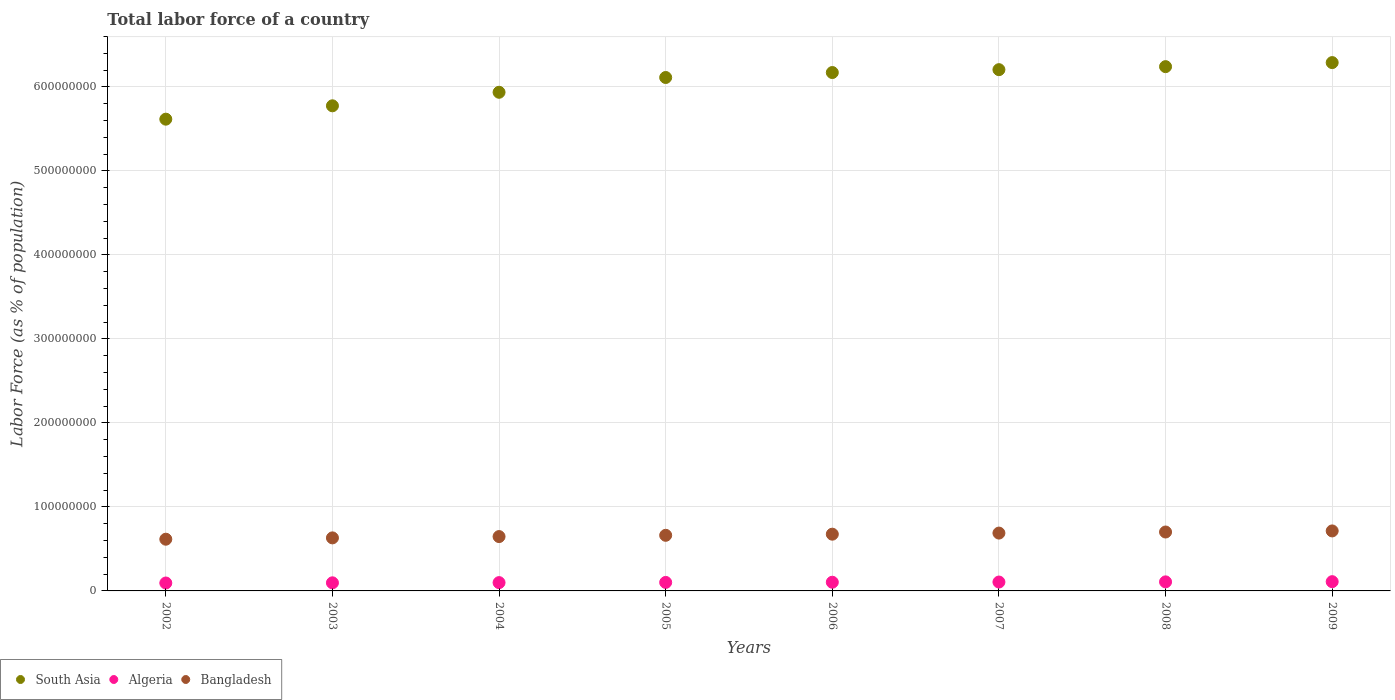How many different coloured dotlines are there?
Provide a short and direct response. 3. Is the number of dotlines equal to the number of legend labels?
Give a very brief answer. Yes. What is the percentage of labor force in Algeria in 2007?
Provide a short and direct response. 1.06e+07. Across all years, what is the maximum percentage of labor force in Bangladesh?
Give a very brief answer. 7.14e+07. Across all years, what is the minimum percentage of labor force in Algeria?
Offer a very short reply. 9.43e+06. What is the total percentage of labor force in Bangladesh in the graph?
Offer a terse response. 5.34e+08. What is the difference between the percentage of labor force in Bangladesh in 2006 and that in 2009?
Provide a succinct answer. -3.87e+06. What is the difference between the percentage of labor force in Algeria in 2003 and the percentage of labor force in Bangladesh in 2005?
Give a very brief answer. -5.66e+07. What is the average percentage of labor force in Algeria per year?
Offer a very short reply. 1.02e+07. In the year 2004, what is the difference between the percentage of labor force in Algeria and percentage of labor force in South Asia?
Your answer should be very brief. -5.84e+08. In how many years, is the percentage of labor force in Bangladesh greater than 80000000 %?
Make the answer very short. 0. What is the ratio of the percentage of labor force in South Asia in 2002 to that in 2003?
Offer a terse response. 0.97. Is the difference between the percentage of labor force in Algeria in 2005 and 2007 greater than the difference between the percentage of labor force in South Asia in 2005 and 2007?
Ensure brevity in your answer.  Yes. What is the difference between the highest and the second highest percentage of labor force in Bangladesh?
Ensure brevity in your answer.  1.29e+06. What is the difference between the highest and the lowest percentage of labor force in Bangladesh?
Provide a succinct answer. 9.86e+06. In how many years, is the percentage of labor force in South Asia greater than the average percentage of labor force in South Asia taken over all years?
Offer a terse response. 5. Does the percentage of labor force in South Asia monotonically increase over the years?
Make the answer very short. Yes. Is the percentage of labor force in South Asia strictly less than the percentage of labor force in Bangladesh over the years?
Keep it short and to the point. No. How many years are there in the graph?
Offer a terse response. 8. Does the graph contain any zero values?
Give a very brief answer. No. How are the legend labels stacked?
Your answer should be very brief. Horizontal. What is the title of the graph?
Provide a succinct answer. Total labor force of a country. What is the label or title of the Y-axis?
Make the answer very short. Labor Force (as % of population). What is the Labor Force (as % of population) in South Asia in 2002?
Your answer should be compact. 5.62e+08. What is the Labor Force (as % of population) of Algeria in 2002?
Offer a very short reply. 9.43e+06. What is the Labor Force (as % of population) of Bangladesh in 2002?
Your answer should be compact. 6.16e+07. What is the Labor Force (as % of population) in South Asia in 2003?
Offer a very short reply. 5.78e+08. What is the Labor Force (as % of population) in Algeria in 2003?
Ensure brevity in your answer.  9.65e+06. What is the Labor Force (as % of population) of Bangladesh in 2003?
Your response must be concise. 6.32e+07. What is the Labor Force (as % of population) in South Asia in 2004?
Provide a succinct answer. 5.94e+08. What is the Labor Force (as % of population) in Algeria in 2004?
Your answer should be very brief. 9.89e+06. What is the Labor Force (as % of population) of Bangladesh in 2004?
Make the answer very short. 6.47e+07. What is the Labor Force (as % of population) in South Asia in 2005?
Your response must be concise. 6.11e+08. What is the Labor Force (as % of population) in Algeria in 2005?
Your answer should be very brief. 1.01e+07. What is the Labor Force (as % of population) of Bangladesh in 2005?
Keep it short and to the point. 6.62e+07. What is the Labor Force (as % of population) in South Asia in 2006?
Your response must be concise. 6.17e+08. What is the Labor Force (as % of population) of Algeria in 2006?
Provide a short and direct response. 1.03e+07. What is the Labor Force (as % of population) of Bangladesh in 2006?
Your answer should be very brief. 6.76e+07. What is the Labor Force (as % of population) of South Asia in 2007?
Provide a short and direct response. 6.21e+08. What is the Labor Force (as % of population) of Algeria in 2007?
Keep it short and to the point. 1.06e+07. What is the Labor Force (as % of population) in Bangladesh in 2007?
Your response must be concise. 6.89e+07. What is the Labor Force (as % of population) in South Asia in 2008?
Make the answer very short. 6.24e+08. What is the Labor Force (as % of population) of Algeria in 2008?
Keep it short and to the point. 1.08e+07. What is the Labor Force (as % of population) of Bangladesh in 2008?
Give a very brief answer. 7.01e+07. What is the Labor Force (as % of population) of South Asia in 2009?
Ensure brevity in your answer.  6.29e+08. What is the Labor Force (as % of population) in Algeria in 2009?
Your answer should be compact. 1.10e+07. What is the Labor Force (as % of population) in Bangladesh in 2009?
Make the answer very short. 7.14e+07. Across all years, what is the maximum Labor Force (as % of population) in South Asia?
Keep it short and to the point. 6.29e+08. Across all years, what is the maximum Labor Force (as % of population) of Algeria?
Give a very brief answer. 1.10e+07. Across all years, what is the maximum Labor Force (as % of population) of Bangladesh?
Keep it short and to the point. 7.14e+07. Across all years, what is the minimum Labor Force (as % of population) in South Asia?
Keep it short and to the point. 5.62e+08. Across all years, what is the minimum Labor Force (as % of population) in Algeria?
Offer a terse response. 9.43e+06. Across all years, what is the minimum Labor Force (as % of population) of Bangladesh?
Make the answer very short. 6.16e+07. What is the total Labor Force (as % of population) in South Asia in the graph?
Your answer should be very brief. 4.84e+09. What is the total Labor Force (as % of population) in Algeria in the graph?
Offer a very short reply. 8.18e+07. What is the total Labor Force (as % of population) in Bangladesh in the graph?
Give a very brief answer. 5.34e+08. What is the difference between the Labor Force (as % of population) in South Asia in 2002 and that in 2003?
Ensure brevity in your answer.  -1.59e+07. What is the difference between the Labor Force (as % of population) of Algeria in 2002 and that in 2003?
Your response must be concise. -2.21e+05. What is the difference between the Labor Force (as % of population) of Bangladesh in 2002 and that in 2003?
Ensure brevity in your answer.  -1.58e+06. What is the difference between the Labor Force (as % of population) in South Asia in 2002 and that in 2004?
Your answer should be compact. -3.20e+07. What is the difference between the Labor Force (as % of population) in Algeria in 2002 and that in 2004?
Provide a succinct answer. -4.60e+05. What is the difference between the Labor Force (as % of population) of Bangladesh in 2002 and that in 2004?
Your answer should be compact. -3.14e+06. What is the difference between the Labor Force (as % of population) in South Asia in 2002 and that in 2005?
Your response must be concise. -4.96e+07. What is the difference between the Labor Force (as % of population) in Algeria in 2002 and that in 2005?
Offer a very short reply. -6.96e+05. What is the difference between the Labor Force (as % of population) of Bangladesh in 2002 and that in 2005?
Provide a short and direct response. -4.65e+06. What is the difference between the Labor Force (as % of population) in South Asia in 2002 and that in 2006?
Ensure brevity in your answer.  -5.55e+07. What is the difference between the Labor Force (as % of population) of Algeria in 2002 and that in 2006?
Your answer should be very brief. -9.16e+05. What is the difference between the Labor Force (as % of population) in Bangladesh in 2002 and that in 2006?
Ensure brevity in your answer.  -5.99e+06. What is the difference between the Labor Force (as % of population) of South Asia in 2002 and that in 2007?
Make the answer very short. -5.90e+07. What is the difference between the Labor Force (as % of population) of Algeria in 2002 and that in 2007?
Offer a very short reply. -1.15e+06. What is the difference between the Labor Force (as % of population) of Bangladesh in 2002 and that in 2007?
Keep it short and to the point. -7.29e+06. What is the difference between the Labor Force (as % of population) of South Asia in 2002 and that in 2008?
Give a very brief answer. -6.25e+07. What is the difference between the Labor Force (as % of population) in Algeria in 2002 and that in 2008?
Offer a terse response. -1.35e+06. What is the difference between the Labor Force (as % of population) of Bangladesh in 2002 and that in 2008?
Offer a terse response. -8.57e+06. What is the difference between the Labor Force (as % of population) in South Asia in 2002 and that in 2009?
Keep it short and to the point. -6.74e+07. What is the difference between the Labor Force (as % of population) in Algeria in 2002 and that in 2009?
Your answer should be very brief. -1.59e+06. What is the difference between the Labor Force (as % of population) in Bangladesh in 2002 and that in 2009?
Ensure brevity in your answer.  -9.86e+06. What is the difference between the Labor Force (as % of population) in South Asia in 2003 and that in 2004?
Your answer should be compact. -1.61e+07. What is the difference between the Labor Force (as % of population) of Algeria in 2003 and that in 2004?
Give a very brief answer. -2.39e+05. What is the difference between the Labor Force (as % of population) in Bangladesh in 2003 and that in 2004?
Give a very brief answer. -1.55e+06. What is the difference between the Labor Force (as % of population) in South Asia in 2003 and that in 2005?
Your answer should be very brief. -3.37e+07. What is the difference between the Labor Force (as % of population) of Algeria in 2003 and that in 2005?
Your response must be concise. -4.75e+05. What is the difference between the Labor Force (as % of population) of Bangladesh in 2003 and that in 2005?
Ensure brevity in your answer.  -3.06e+06. What is the difference between the Labor Force (as % of population) of South Asia in 2003 and that in 2006?
Provide a succinct answer. -3.96e+07. What is the difference between the Labor Force (as % of population) in Algeria in 2003 and that in 2006?
Offer a terse response. -6.95e+05. What is the difference between the Labor Force (as % of population) of Bangladesh in 2003 and that in 2006?
Your answer should be compact. -4.41e+06. What is the difference between the Labor Force (as % of population) of South Asia in 2003 and that in 2007?
Make the answer very short. -4.30e+07. What is the difference between the Labor Force (as % of population) of Algeria in 2003 and that in 2007?
Keep it short and to the point. -9.28e+05. What is the difference between the Labor Force (as % of population) of Bangladesh in 2003 and that in 2007?
Ensure brevity in your answer.  -5.71e+06. What is the difference between the Labor Force (as % of population) in South Asia in 2003 and that in 2008?
Your answer should be compact. -4.66e+07. What is the difference between the Labor Force (as % of population) of Algeria in 2003 and that in 2008?
Offer a very short reply. -1.13e+06. What is the difference between the Labor Force (as % of population) in Bangladesh in 2003 and that in 2008?
Provide a succinct answer. -6.99e+06. What is the difference between the Labor Force (as % of population) of South Asia in 2003 and that in 2009?
Your answer should be compact. -5.14e+07. What is the difference between the Labor Force (as % of population) of Algeria in 2003 and that in 2009?
Your answer should be compact. -1.37e+06. What is the difference between the Labor Force (as % of population) in Bangladesh in 2003 and that in 2009?
Keep it short and to the point. -8.28e+06. What is the difference between the Labor Force (as % of population) of South Asia in 2004 and that in 2005?
Offer a terse response. -1.76e+07. What is the difference between the Labor Force (as % of population) in Algeria in 2004 and that in 2005?
Your answer should be compact. -2.35e+05. What is the difference between the Labor Force (as % of population) in Bangladesh in 2004 and that in 2005?
Give a very brief answer. -1.51e+06. What is the difference between the Labor Force (as % of population) of South Asia in 2004 and that in 2006?
Make the answer very short. -2.35e+07. What is the difference between the Labor Force (as % of population) in Algeria in 2004 and that in 2006?
Your answer should be compact. -4.55e+05. What is the difference between the Labor Force (as % of population) of Bangladesh in 2004 and that in 2006?
Make the answer very short. -2.85e+06. What is the difference between the Labor Force (as % of population) in South Asia in 2004 and that in 2007?
Your answer should be very brief. -2.69e+07. What is the difference between the Labor Force (as % of population) of Algeria in 2004 and that in 2007?
Your response must be concise. -6.88e+05. What is the difference between the Labor Force (as % of population) in Bangladesh in 2004 and that in 2007?
Offer a very short reply. -4.15e+06. What is the difference between the Labor Force (as % of population) in South Asia in 2004 and that in 2008?
Give a very brief answer. -3.05e+07. What is the difference between the Labor Force (as % of population) in Algeria in 2004 and that in 2008?
Your response must be concise. -8.87e+05. What is the difference between the Labor Force (as % of population) of Bangladesh in 2004 and that in 2008?
Provide a succinct answer. -5.44e+06. What is the difference between the Labor Force (as % of population) in South Asia in 2004 and that in 2009?
Make the answer very short. -3.53e+07. What is the difference between the Labor Force (as % of population) of Algeria in 2004 and that in 2009?
Keep it short and to the point. -1.13e+06. What is the difference between the Labor Force (as % of population) of Bangladesh in 2004 and that in 2009?
Make the answer very short. -6.73e+06. What is the difference between the Labor Force (as % of population) of South Asia in 2005 and that in 2006?
Keep it short and to the point. -5.91e+06. What is the difference between the Labor Force (as % of population) in Algeria in 2005 and that in 2006?
Make the answer very short. -2.20e+05. What is the difference between the Labor Force (as % of population) of Bangladesh in 2005 and that in 2006?
Offer a very short reply. -1.34e+06. What is the difference between the Labor Force (as % of population) in South Asia in 2005 and that in 2007?
Provide a succinct answer. -9.34e+06. What is the difference between the Labor Force (as % of population) of Algeria in 2005 and that in 2007?
Offer a very short reply. -4.53e+05. What is the difference between the Labor Force (as % of population) of Bangladesh in 2005 and that in 2007?
Keep it short and to the point. -2.65e+06. What is the difference between the Labor Force (as % of population) in South Asia in 2005 and that in 2008?
Provide a short and direct response. -1.29e+07. What is the difference between the Labor Force (as % of population) in Algeria in 2005 and that in 2008?
Your answer should be very brief. -6.52e+05. What is the difference between the Labor Force (as % of population) in Bangladesh in 2005 and that in 2008?
Your answer should be very brief. -3.93e+06. What is the difference between the Labor Force (as % of population) in South Asia in 2005 and that in 2009?
Your answer should be compact. -1.77e+07. What is the difference between the Labor Force (as % of population) in Algeria in 2005 and that in 2009?
Offer a very short reply. -8.95e+05. What is the difference between the Labor Force (as % of population) in Bangladesh in 2005 and that in 2009?
Your response must be concise. -5.22e+06. What is the difference between the Labor Force (as % of population) in South Asia in 2006 and that in 2007?
Your answer should be very brief. -3.43e+06. What is the difference between the Labor Force (as % of population) in Algeria in 2006 and that in 2007?
Your answer should be very brief. -2.33e+05. What is the difference between the Labor Force (as % of population) of Bangladesh in 2006 and that in 2007?
Provide a succinct answer. -1.30e+06. What is the difference between the Labor Force (as % of population) in South Asia in 2006 and that in 2008?
Give a very brief answer. -7.01e+06. What is the difference between the Labor Force (as % of population) in Algeria in 2006 and that in 2008?
Ensure brevity in your answer.  -4.32e+05. What is the difference between the Labor Force (as % of population) in Bangladesh in 2006 and that in 2008?
Ensure brevity in your answer.  -2.58e+06. What is the difference between the Labor Force (as % of population) of South Asia in 2006 and that in 2009?
Give a very brief answer. -1.18e+07. What is the difference between the Labor Force (as % of population) of Algeria in 2006 and that in 2009?
Provide a short and direct response. -6.75e+05. What is the difference between the Labor Force (as % of population) in Bangladesh in 2006 and that in 2009?
Your answer should be compact. -3.87e+06. What is the difference between the Labor Force (as % of population) in South Asia in 2007 and that in 2008?
Ensure brevity in your answer.  -3.58e+06. What is the difference between the Labor Force (as % of population) of Algeria in 2007 and that in 2008?
Offer a very short reply. -1.99e+05. What is the difference between the Labor Force (as % of population) of Bangladesh in 2007 and that in 2008?
Offer a very short reply. -1.28e+06. What is the difference between the Labor Force (as % of population) in South Asia in 2007 and that in 2009?
Make the answer very short. -8.41e+06. What is the difference between the Labor Force (as % of population) of Algeria in 2007 and that in 2009?
Your answer should be very brief. -4.42e+05. What is the difference between the Labor Force (as % of population) of Bangladesh in 2007 and that in 2009?
Your response must be concise. -2.57e+06. What is the difference between the Labor Force (as % of population) of South Asia in 2008 and that in 2009?
Your answer should be very brief. -4.82e+06. What is the difference between the Labor Force (as % of population) in Algeria in 2008 and that in 2009?
Your answer should be compact. -2.43e+05. What is the difference between the Labor Force (as % of population) in Bangladesh in 2008 and that in 2009?
Give a very brief answer. -1.29e+06. What is the difference between the Labor Force (as % of population) in South Asia in 2002 and the Labor Force (as % of population) in Algeria in 2003?
Provide a short and direct response. 5.52e+08. What is the difference between the Labor Force (as % of population) in South Asia in 2002 and the Labor Force (as % of population) in Bangladesh in 2003?
Offer a terse response. 4.99e+08. What is the difference between the Labor Force (as % of population) of Algeria in 2002 and the Labor Force (as % of population) of Bangladesh in 2003?
Your response must be concise. -5.37e+07. What is the difference between the Labor Force (as % of population) of South Asia in 2002 and the Labor Force (as % of population) of Algeria in 2004?
Your response must be concise. 5.52e+08. What is the difference between the Labor Force (as % of population) of South Asia in 2002 and the Labor Force (as % of population) of Bangladesh in 2004?
Ensure brevity in your answer.  4.97e+08. What is the difference between the Labor Force (as % of population) of Algeria in 2002 and the Labor Force (as % of population) of Bangladesh in 2004?
Give a very brief answer. -5.53e+07. What is the difference between the Labor Force (as % of population) in South Asia in 2002 and the Labor Force (as % of population) in Algeria in 2005?
Give a very brief answer. 5.52e+08. What is the difference between the Labor Force (as % of population) of South Asia in 2002 and the Labor Force (as % of population) of Bangladesh in 2005?
Your response must be concise. 4.95e+08. What is the difference between the Labor Force (as % of population) in Algeria in 2002 and the Labor Force (as % of population) in Bangladesh in 2005?
Provide a short and direct response. -5.68e+07. What is the difference between the Labor Force (as % of population) of South Asia in 2002 and the Labor Force (as % of population) of Algeria in 2006?
Your response must be concise. 5.51e+08. What is the difference between the Labor Force (as % of population) of South Asia in 2002 and the Labor Force (as % of population) of Bangladesh in 2006?
Provide a succinct answer. 4.94e+08. What is the difference between the Labor Force (as % of population) in Algeria in 2002 and the Labor Force (as % of population) in Bangladesh in 2006?
Your answer should be compact. -5.81e+07. What is the difference between the Labor Force (as % of population) of South Asia in 2002 and the Labor Force (as % of population) of Algeria in 2007?
Keep it short and to the point. 5.51e+08. What is the difference between the Labor Force (as % of population) of South Asia in 2002 and the Labor Force (as % of population) of Bangladesh in 2007?
Your response must be concise. 4.93e+08. What is the difference between the Labor Force (as % of population) in Algeria in 2002 and the Labor Force (as % of population) in Bangladesh in 2007?
Offer a very short reply. -5.94e+07. What is the difference between the Labor Force (as % of population) of South Asia in 2002 and the Labor Force (as % of population) of Algeria in 2008?
Give a very brief answer. 5.51e+08. What is the difference between the Labor Force (as % of population) of South Asia in 2002 and the Labor Force (as % of population) of Bangladesh in 2008?
Offer a terse response. 4.92e+08. What is the difference between the Labor Force (as % of population) of Algeria in 2002 and the Labor Force (as % of population) of Bangladesh in 2008?
Ensure brevity in your answer.  -6.07e+07. What is the difference between the Labor Force (as % of population) of South Asia in 2002 and the Labor Force (as % of population) of Algeria in 2009?
Offer a terse response. 5.51e+08. What is the difference between the Labor Force (as % of population) of South Asia in 2002 and the Labor Force (as % of population) of Bangladesh in 2009?
Make the answer very short. 4.90e+08. What is the difference between the Labor Force (as % of population) of Algeria in 2002 and the Labor Force (as % of population) of Bangladesh in 2009?
Make the answer very short. -6.20e+07. What is the difference between the Labor Force (as % of population) in South Asia in 2003 and the Labor Force (as % of population) in Algeria in 2004?
Make the answer very short. 5.68e+08. What is the difference between the Labor Force (as % of population) in South Asia in 2003 and the Labor Force (as % of population) in Bangladesh in 2004?
Provide a succinct answer. 5.13e+08. What is the difference between the Labor Force (as % of population) of Algeria in 2003 and the Labor Force (as % of population) of Bangladesh in 2004?
Give a very brief answer. -5.51e+07. What is the difference between the Labor Force (as % of population) in South Asia in 2003 and the Labor Force (as % of population) in Algeria in 2005?
Keep it short and to the point. 5.67e+08. What is the difference between the Labor Force (as % of population) of South Asia in 2003 and the Labor Force (as % of population) of Bangladesh in 2005?
Give a very brief answer. 5.11e+08. What is the difference between the Labor Force (as % of population) of Algeria in 2003 and the Labor Force (as % of population) of Bangladesh in 2005?
Your response must be concise. -5.66e+07. What is the difference between the Labor Force (as % of population) in South Asia in 2003 and the Labor Force (as % of population) in Algeria in 2006?
Your answer should be compact. 5.67e+08. What is the difference between the Labor Force (as % of population) in South Asia in 2003 and the Labor Force (as % of population) in Bangladesh in 2006?
Offer a terse response. 5.10e+08. What is the difference between the Labor Force (as % of population) in Algeria in 2003 and the Labor Force (as % of population) in Bangladesh in 2006?
Offer a very short reply. -5.79e+07. What is the difference between the Labor Force (as % of population) of South Asia in 2003 and the Labor Force (as % of population) of Algeria in 2007?
Offer a very short reply. 5.67e+08. What is the difference between the Labor Force (as % of population) in South Asia in 2003 and the Labor Force (as % of population) in Bangladesh in 2007?
Give a very brief answer. 5.09e+08. What is the difference between the Labor Force (as % of population) in Algeria in 2003 and the Labor Force (as % of population) in Bangladesh in 2007?
Provide a short and direct response. -5.92e+07. What is the difference between the Labor Force (as % of population) of South Asia in 2003 and the Labor Force (as % of population) of Algeria in 2008?
Offer a terse response. 5.67e+08. What is the difference between the Labor Force (as % of population) in South Asia in 2003 and the Labor Force (as % of population) in Bangladesh in 2008?
Offer a very short reply. 5.07e+08. What is the difference between the Labor Force (as % of population) in Algeria in 2003 and the Labor Force (as % of population) in Bangladesh in 2008?
Provide a short and direct response. -6.05e+07. What is the difference between the Labor Force (as % of population) in South Asia in 2003 and the Labor Force (as % of population) in Algeria in 2009?
Your answer should be compact. 5.67e+08. What is the difference between the Labor Force (as % of population) in South Asia in 2003 and the Labor Force (as % of population) in Bangladesh in 2009?
Ensure brevity in your answer.  5.06e+08. What is the difference between the Labor Force (as % of population) of Algeria in 2003 and the Labor Force (as % of population) of Bangladesh in 2009?
Offer a terse response. -6.18e+07. What is the difference between the Labor Force (as % of population) in South Asia in 2004 and the Labor Force (as % of population) in Algeria in 2005?
Your response must be concise. 5.84e+08. What is the difference between the Labor Force (as % of population) of South Asia in 2004 and the Labor Force (as % of population) of Bangladesh in 2005?
Ensure brevity in your answer.  5.27e+08. What is the difference between the Labor Force (as % of population) of Algeria in 2004 and the Labor Force (as % of population) of Bangladesh in 2005?
Give a very brief answer. -5.63e+07. What is the difference between the Labor Force (as % of population) of South Asia in 2004 and the Labor Force (as % of population) of Algeria in 2006?
Keep it short and to the point. 5.83e+08. What is the difference between the Labor Force (as % of population) in South Asia in 2004 and the Labor Force (as % of population) in Bangladesh in 2006?
Provide a succinct answer. 5.26e+08. What is the difference between the Labor Force (as % of population) in Algeria in 2004 and the Labor Force (as % of population) in Bangladesh in 2006?
Keep it short and to the point. -5.77e+07. What is the difference between the Labor Force (as % of population) in South Asia in 2004 and the Labor Force (as % of population) in Algeria in 2007?
Your answer should be compact. 5.83e+08. What is the difference between the Labor Force (as % of population) in South Asia in 2004 and the Labor Force (as % of population) in Bangladesh in 2007?
Your answer should be compact. 5.25e+08. What is the difference between the Labor Force (as % of population) in Algeria in 2004 and the Labor Force (as % of population) in Bangladesh in 2007?
Keep it short and to the point. -5.90e+07. What is the difference between the Labor Force (as % of population) in South Asia in 2004 and the Labor Force (as % of population) in Algeria in 2008?
Your answer should be compact. 5.83e+08. What is the difference between the Labor Force (as % of population) of South Asia in 2004 and the Labor Force (as % of population) of Bangladesh in 2008?
Offer a terse response. 5.24e+08. What is the difference between the Labor Force (as % of population) of Algeria in 2004 and the Labor Force (as % of population) of Bangladesh in 2008?
Offer a very short reply. -6.03e+07. What is the difference between the Labor Force (as % of population) in South Asia in 2004 and the Labor Force (as % of population) in Algeria in 2009?
Provide a short and direct response. 5.83e+08. What is the difference between the Labor Force (as % of population) in South Asia in 2004 and the Labor Force (as % of population) in Bangladesh in 2009?
Offer a very short reply. 5.22e+08. What is the difference between the Labor Force (as % of population) of Algeria in 2004 and the Labor Force (as % of population) of Bangladesh in 2009?
Give a very brief answer. -6.15e+07. What is the difference between the Labor Force (as % of population) in South Asia in 2005 and the Labor Force (as % of population) in Algeria in 2006?
Provide a succinct answer. 6.01e+08. What is the difference between the Labor Force (as % of population) of South Asia in 2005 and the Labor Force (as % of population) of Bangladesh in 2006?
Keep it short and to the point. 5.44e+08. What is the difference between the Labor Force (as % of population) in Algeria in 2005 and the Labor Force (as % of population) in Bangladesh in 2006?
Your response must be concise. -5.74e+07. What is the difference between the Labor Force (as % of population) of South Asia in 2005 and the Labor Force (as % of population) of Algeria in 2007?
Ensure brevity in your answer.  6.01e+08. What is the difference between the Labor Force (as % of population) in South Asia in 2005 and the Labor Force (as % of population) in Bangladesh in 2007?
Provide a succinct answer. 5.42e+08. What is the difference between the Labor Force (as % of population) of Algeria in 2005 and the Labor Force (as % of population) of Bangladesh in 2007?
Provide a succinct answer. -5.87e+07. What is the difference between the Labor Force (as % of population) in South Asia in 2005 and the Labor Force (as % of population) in Algeria in 2008?
Provide a short and direct response. 6.01e+08. What is the difference between the Labor Force (as % of population) of South Asia in 2005 and the Labor Force (as % of population) of Bangladesh in 2008?
Your response must be concise. 5.41e+08. What is the difference between the Labor Force (as % of population) of Algeria in 2005 and the Labor Force (as % of population) of Bangladesh in 2008?
Ensure brevity in your answer.  -6.00e+07. What is the difference between the Labor Force (as % of population) of South Asia in 2005 and the Labor Force (as % of population) of Algeria in 2009?
Provide a short and direct response. 6.00e+08. What is the difference between the Labor Force (as % of population) in South Asia in 2005 and the Labor Force (as % of population) in Bangladesh in 2009?
Your answer should be very brief. 5.40e+08. What is the difference between the Labor Force (as % of population) in Algeria in 2005 and the Labor Force (as % of population) in Bangladesh in 2009?
Keep it short and to the point. -6.13e+07. What is the difference between the Labor Force (as % of population) of South Asia in 2006 and the Labor Force (as % of population) of Algeria in 2007?
Keep it short and to the point. 6.07e+08. What is the difference between the Labor Force (as % of population) of South Asia in 2006 and the Labor Force (as % of population) of Bangladesh in 2007?
Provide a short and direct response. 5.48e+08. What is the difference between the Labor Force (as % of population) of Algeria in 2006 and the Labor Force (as % of population) of Bangladesh in 2007?
Keep it short and to the point. -5.85e+07. What is the difference between the Labor Force (as % of population) in South Asia in 2006 and the Labor Force (as % of population) in Algeria in 2008?
Offer a terse response. 6.06e+08. What is the difference between the Labor Force (as % of population) of South Asia in 2006 and the Labor Force (as % of population) of Bangladesh in 2008?
Keep it short and to the point. 5.47e+08. What is the difference between the Labor Force (as % of population) in Algeria in 2006 and the Labor Force (as % of population) in Bangladesh in 2008?
Your answer should be very brief. -5.98e+07. What is the difference between the Labor Force (as % of population) in South Asia in 2006 and the Labor Force (as % of population) in Algeria in 2009?
Your answer should be compact. 6.06e+08. What is the difference between the Labor Force (as % of population) in South Asia in 2006 and the Labor Force (as % of population) in Bangladesh in 2009?
Your answer should be compact. 5.46e+08. What is the difference between the Labor Force (as % of population) of Algeria in 2006 and the Labor Force (as % of population) of Bangladesh in 2009?
Your answer should be very brief. -6.11e+07. What is the difference between the Labor Force (as % of population) in South Asia in 2007 and the Labor Force (as % of population) in Algeria in 2008?
Offer a very short reply. 6.10e+08. What is the difference between the Labor Force (as % of population) in South Asia in 2007 and the Labor Force (as % of population) in Bangladesh in 2008?
Provide a succinct answer. 5.51e+08. What is the difference between the Labor Force (as % of population) in Algeria in 2007 and the Labor Force (as % of population) in Bangladesh in 2008?
Provide a short and direct response. -5.96e+07. What is the difference between the Labor Force (as % of population) of South Asia in 2007 and the Labor Force (as % of population) of Algeria in 2009?
Provide a succinct answer. 6.10e+08. What is the difference between the Labor Force (as % of population) in South Asia in 2007 and the Labor Force (as % of population) in Bangladesh in 2009?
Your answer should be very brief. 5.49e+08. What is the difference between the Labor Force (as % of population) in Algeria in 2007 and the Labor Force (as % of population) in Bangladesh in 2009?
Make the answer very short. -6.09e+07. What is the difference between the Labor Force (as % of population) in South Asia in 2008 and the Labor Force (as % of population) in Algeria in 2009?
Your response must be concise. 6.13e+08. What is the difference between the Labor Force (as % of population) in South Asia in 2008 and the Labor Force (as % of population) in Bangladesh in 2009?
Offer a very short reply. 5.53e+08. What is the difference between the Labor Force (as % of population) of Algeria in 2008 and the Labor Force (as % of population) of Bangladesh in 2009?
Provide a succinct answer. -6.07e+07. What is the average Labor Force (as % of population) in South Asia per year?
Your answer should be very brief. 6.04e+08. What is the average Labor Force (as % of population) in Algeria per year?
Your response must be concise. 1.02e+07. What is the average Labor Force (as % of population) in Bangladesh per year?
Your answer should be compact. 6.67e+07. In the year 2002, what is the difference between the Labor Force (as % of population) in South Asia and Labor Force (as % of population) in Algeria?
Your answer should be compact. 5.52e+08. In the year 2002, what is the difference between the Labor Force (as % of population) of South Asia and Labor Force (as % of population) of Bangladesh?
Give a very brief answer. 5.00e+08. In the year 2002, what is the difference between the Labor Force (as % of population) in Algeria and Labor Force (as % of population) in Bangladesh?
Provide a short and direct response. -5.21e+07. In the year 2003, what is the difference between the Labor Force (as % of population) of South Asia and Labor Force (as % of population) of Algeria?
Provide a short and direct response. 5.68e+08. In the year 2003, what is the difference between the Labor Force (as % of population) in South Asia and Labor Force (as % of population) in Bangladesh?
Ensure brevity in your answer.  5.14e+08. In the year 2003, what is the difference between the Labor Force (as % of population) of Algeria and Labor Force (as % of population) of Bangladesh?
Your answer should be very brief. -5.35e+07. In the year 2004, what is the difference between the Labor Force (as % of population) of South Asia and Labor Force (as % of population) of Algeria?
Offer a very short reply. 5.84e+08. In the year 2004, what is the difference between the Labor Force (as % of population) of South Asia and Labor Force (as % of population) of Bangladesh?
Make the answer very short. 5.29e+08. In the year 2004, what is the difference between the Labor Force (as % of population) in Algeria and Labor Force (as % of population) in Bangladesh?
Provide a succinct answer. -5.48e+07. In the year 2005, what is the difference between the Labor Force (as % of population) in South Asia and Labor Force (as % of population) in Algeria?
Offer a terse response. 6.01e+08. In the year 2005, what is the difference between the Labor Force (as % of population) in South Asia and Labor Force (as % of population) in Bangladesh?
Provide a succinct answer. 5.45e+08. In the year 2005, what is the difference between the Labor Force (as % of population) of Algeria and Labor Force (as % of population) of Bangladesh?
Provide a short and direct response. -5.61e+07. In the year 2006, what is the difference between the Labor Force (as % of population) in South Asia and Labor Force (as % of population) in Algeria?
Ensure brevity in your answer.  6.07e+08. In the year 2006, what is the difference between the Labor Force (as % of population) of South Asia and Labor Force (as % of population) of Bangladesh?
Your response must be concise. 5.50e+08. In the year 2006, what is the difference between the Labor Force (as % of population) of Algeria and Labor Force (as % of population) of Bangladesh?
Provide a succinct answer. -5.72e+07. In the year 2007, what is the difference between the Labor Force (as % of population) in South Asia and Labor Force (as % of population) in Algeria?
Provide a short and direct response. 6.10e+08. In the year 2007, what is the difference between the Labor Force (as % of population) of South Asia and Labor Force (as % of population) of Bangladesh?
Make the answer very short. 5.52e+08. In the year 2007, what is the difference between the Labor Force (as % of population) of Algeria and Labor Force (as % of population) of Bangladesh?
Provide a succinct answer. -5.83e+07. In the year 2008, what is the difference between the Labor Force (as % of population) in South Asia and Labor Force (as % of population) in Algeria?
Your answer should be very brief. 6.13e+08. In the year 2008, what is the difference between the Labor Force (as % of population) of South Asia and Labor Force (as % of population) of Bangladesh?
Make the answer very short. 5.54e+08. In the year 2008, what is the difference between the Labor Force (as % of population) in Algeria and Labor Force (as % of population) in Bangladesh?
Give a very brief answer. -5.94e+07. In the year 2009, what is the difference between the Labor Force (as % of population) in South Asia and Labor Force (as % of population) in Algeria?
Provide a succinct answer. 6.18e+08. In the year 2009, what is the difference between the Labor Force (as % of population) of South Asia and Labor Force (as % of population) of Bangladesh?
Offer a terse response. 5.58e+08. In the year 2009, what is the difference between the Labor Force (as % of population) of Algeria and Labor Force (as % of population) of Bangladesh?
Your answer should be very brief. -6.04e+07. What is the ratio of the Labor Force (as % of population) of South Asia in 2002 to that in 2003?
Provide a succinct answer. 0.97. What is the ratio of the Labor Force (as % of population) in Algeria in 2002 to that in 2003?
Offer a very short reply. 0.98. What is the ratio of the Labor Force (as % of population) of Bangladesh in 2002 to that in 2003?
Keep it short and to the point. 0.97. What is the ratio of the Labor Force (as % of population) in South Asia in 2002 to that in 2004?
Your response must be concise. 0.95. What is the ratio of the Labor Force (as % of population) of Algeria in 2002 to that in 2004?
Give a very brief answer. 0.95. What is the ratio of the Labor Force (as % of population) in Bangladesh in 2002 to that in 2004?
Your answer should be compact. 0.95. What is the ratio of the Labor Force (as % of population) of South Asia in 2002 to that in 2005?
Your response must be concise. 0.92. What is the ratio of the Labor Force (as % of population) of Algeria in 2002 to that in 2005?
Keep it short and to the point. 0.93. What is the ratio of the Labor Force (as % of population) in Bangladesh in 2002 to that in 2005?
Provide a succinct answer. 0.93. What is the ratio of the Labor Force (as % of population) of South Asia in 2002 to that in 2006?
Provide a succinct answer. 0.91. What is the ratio of the Labor Force (as % of population) of Algeria in 2002 to that in 2006?
Ensure brevity in your answer.  0.91. What is the ratio of the Labor Force (as % of population) of Bangladesh in 2002 to that in 2006?
Provide a short and direct response. 0.91. What is the ratio of the Labor Force (as % of population) in South Asia in 2002 to that in 2007?
Provide a succinct answer. 0.91. What is the ratio of the Labor Force (as % of population) of Algeria in 2002 to that in 2007?
Offer a very short reply. 0.89. What is the ratio of the Labor Force (as % of population) of Bangladesh in 2002 to that in 2007?
Give a very brief answer. 0.89. What is the ratio of the Labor Force (as % of population) in South Asia in 2002 to that in 2008?
Offer a terse response. 0.9. What is the ratio of the Labor Force (as % of population) in Algeria in 2002 to that in 2008?
Make the answer very short. 0.87. What is the ratio of the Labor Force (as % of population) of Bangladesh in 2002 to that in 2008?
Keep it short and to the point. 0.88. What is the ratio of the Labor Force (as % of population) of South Asia in 2002 to that in 2009?
Provide a short and direct response. 0.89. What is the ratio of the Labor Force (as % of population) of Algeria in 2002 to that in 2009?
Provide a succinct answer. 0.86. What is the ratio of the Labor Force (as % of population) in Bangladesh in 2002 to that in 2009?
Make the answer very short. 0.86. What is the ratio of the Labor Force (as % of population) of South Asia in 2003 to that in 2004?
Ensure brevity in your answer.  0.97. What is the ratio of the Labor Force (as % of population) of Algeria in 2003 to that in 2004?
Ensure brevity in your answer.  0.98. What is the ratio of the Labor Force (as % of population) of South Asia in 2003 to that in 2005?
Make the answer very short. 0.94. What is the ratio of the Labor Force (as % of population) in Algeria in 2003 to that in 2005?
Ensure brevity in your answer.  0.95. What is the ratio of the Labor Force (as % of population) of Bangladesh in 2003 to that in 2005?
Offer a very short reply. 0.95. What is the ratio of the Labor Force (as % of population) in South Asia in 2003 to that in 2006?
Provide a succinct answer. 0.94. What is the ratio of the Labor Force (as % of population) of Algeria in 2003 to that in 2006?
Your response must be concise. 0.93. What is the ratio of the Labor Force (as % of population) of Bangladesh in 2003 to that in 2006?
Offer a very short reply. 0.93. What is the ratio of the Labor Force (as % of population) in South Asia in 2003 to that in 2007?
Your answer should be very brief. 0.93. What is the ratio of the Labor Force (as % of population) of Algeria in 2003 to that in 2007?
Keep it short and to the point. 0.91. What is the ratio of the Labor Force (as % of population) of Bangladesh in 2003 to that in 2007?
Ensure brevity in your answer.  0.92. What is the ratio of the Labor Force (as % of population) in South Asia in 2003 to that in 2008?
Provide a short and direct response. 0.93. What is the ratio of the Labor Force (as % of population) of Algeria in 2003 to that in 2008?
Make the answer very short. 0.9. What is the ratio of the Labor Force (as % of population) in Bangladesh in 2003 to that in 2008?
Provide a succinct answer. 0.9. What is the ratio of the Labor Force (as % of population) in South Asia in 2003 to that in 2009?
Provide a short and direct response. 0.92. What is the ratio of the Labor Force (as % of population) in Algeria in 2003 to that in 2009?
Offer a very short reply. 0.88. What is the ratio of the Labor Force (as % of population) of Bangladesh in 2003 to that in 2009?
Keep it short and to the point. 0.88. What is the ratio of the Labor Force (as % of population) of South Asia in 2004 to that in 2005?
Provide a succinct answer. 0.97. What is the ratio of the Labor Force (as % of population) in Algeria in 2004 to that in 2005?
Make the answer very short. 0.98. What is the ratio of the Labor Force (as % of population) of Bangladesh in 2004 to that in 2005?
Ensure brevity in your answer.  0.98. What is the ratio of the Labor Force (as % of population) of South Asia in 2004 to that in 2006?
Ensure brevity in your answer.  0.96. What is the ratio of the Labor Force (as % of population) of Algeria in 2004 to that in 2006?
Your answer should be very brief. 0.96. What is the ratio of the Labor Force (as % of population) of Bangladesh in 2004 to that in 2006?
Offer a very short reply. 0.96. What is the ratio of the Labor Force (as % of population) in South Asia in 2004 to that in 2007?
Keep it short and to the point. 0.96. What is the ratio of the Labor Force (as % of population) in Algeria in 2004 to that in 2007?
Your answer should be compact. 0.93. What is the ratio of the Labor Force (as % of population) of Bangladesh in 2004 to that in 2007?
Give a very brief answer. 0.94. What is the ratio of the Labor Force (as % of population) of South Asia in 2004 to that in 2008?
Your response must be concise. 0.95. What is the ratio of the Labor Force (as % of population) of Algeria in 2004 to that in 2008?
Your response must be concise. 0.92. What is the ratio of the Labor Force (as % of population) in Bangladesh in 2004 to that in 2008?
Provide a succinct answer. 0.92. What is the ratio of the Labor Force (as % of population) in South Asia in 2004 to that in 2009?
Your answer should be very brief. 0.94. What is the ratio of the Labor Force (as % of population) in Algeria in 2004 to that in 2009?
Give a very brief answer. 0.9. What is the ratio of the Labor Force (as % of population) in Bangladesh in 2004 to that in 2009?
Your response must be concise. 0.91. What is the ratio of the Labor Force (as % of population) in South Asia in 2005 to that in 2006?
Ensure brevity in your answer.  0.99. What is the ratio of the Labor Force (as % of population) in Algeria in 2005 to that in 2006?
Offer a terse response. 0.98. What is the ratio of the Labor Force (as % of population) in Bangladesh in 2005 to that in 2006?
Your response must be concise. 0.98. What is the ratio of the Labor Force (as % of population) in South Asia in 2005 to that in 2007?
Make the answer very short. 0.98. What is the ratio of the Labor Force (as % of population) of Algeria in 2005 to that in 2007?
Keep it short and to the point. 0.96. What is the ratio of the Labor Force (as % of population) of Bangladesh in 2005 to that in 2007?
Your answer should be compact. 0.96. What is the ratio of the Labor Force (as % of population) in South Asia in 2005 to that in 2008?
Your answer should be very brief. 0.98. What is the ratio of the Labor Force (as % of population) in Algeria in 2005 to that in 2008?
Provide a short and direct response. 0.94. What is the ratio of the Labor Force (as % of population) of Bangladesh in 2005 to that in 2008?
Provide a short and direct response. 0.94. What is the ratio of the Labor Force (as % of population) in South Asia in 2005 to that in 2009?
Provide a short and direct response. 0.97. What is the ratio of the Labor Force (as % of population) in Algeria in 2005 to that in 2009?
Make the answer very short. 0.92. What is the ratio of the Labor Force (as % of population) of Bangladesh in 2005 to that in 2009?
Give a very brief answer. 0.93. What is the ratio of the Labor Force (as % of population) of Bangladesh in 2006 to that in 2007?
Offer a very short reply. 0.98. What is the ratio of the Labor Force (as % of population) in South Asia in 2006 to that in 2008?
Provide a short and direct response. 0.99. What is the ratio of the Labor Force (as % of population) of Algeria in 2006 to that in 2008?
Ensure brevity in your answer.  0.96. What is the ratio of the Labor Force (as % of population) of Bangladesh in 2006 to that in 2008?
Give a very brief answer. 0.96. What is the ratio of the Labor Force (as % of population) of South Asia in 2006 to that in 2009?
Your response must be concise. 0.98. What is the ratio of the Labor Force (as % of population) in Algeria in 2006 to that in 2009?
Make the answer very short. 0.94. What is the ratio of the Labor Force (as % of population) in Bangladesh in 2006 to that in 2009?
Offer a very short reply. 0.95. What is the ratio of the Labor Force (as % of population) in South Asia in 2007 to that in 2008?
Provide a succinct answer. 0.99. What is the ratio of the Labor Force (as % of population) of Algeria in 2007 to that in 2008?
Keep it short and to the point. 0.98. What is the ratio of the Labor Force (as % of population) of Bangladesh in 2007 to that in 2008?
Your answer should be very brief. 0.98. What is the ratio of the Labor Force (as % of population) in South Asia in 2007 to that in 2009?
Give a very brief answer. 0.99. What is the ratio of the Labor Force (as % of population) of Algeria in 2007 to that in 2009?
Provide a succinct answer. 0.96. What is the ratio of the Labor Force (as % of population) in Bangladesh in 2007 to that in 2009?
Make the answer very short. 0.96. What is the ratio of the Labor Force (as % of population) in Algeria in 2008 to that in 2009?
Your response must be concise. 0.98. What is the difference between the highest and the second highest Labor Force (as % of population) of South Asia?
Provide a succinct answer. 4.82e+06. What is the difference between the highest and the second highest Labor Force (as % of population) in Algeria?
Offer a very short reply. 2.43e+05. What is the difference between the highest and the second highest Labor Force (as % of population) in Bangladesh?
Keep it short and to the point. 1.29e+06. What is the difference between the highest and the lowest Labor Force (as % of population) of South Asia?
Your answer should be compact. 6.74e+07. What is the difference between the highest and the lowest Labor Force (as % of population) of Algeria?
Your response must be concise. 1.59e+06. What is the difference between the highest and the lowest Labor Force (as % of population) in Bangladesh?
Ensure brevity in your answer.  9.86e+06. 